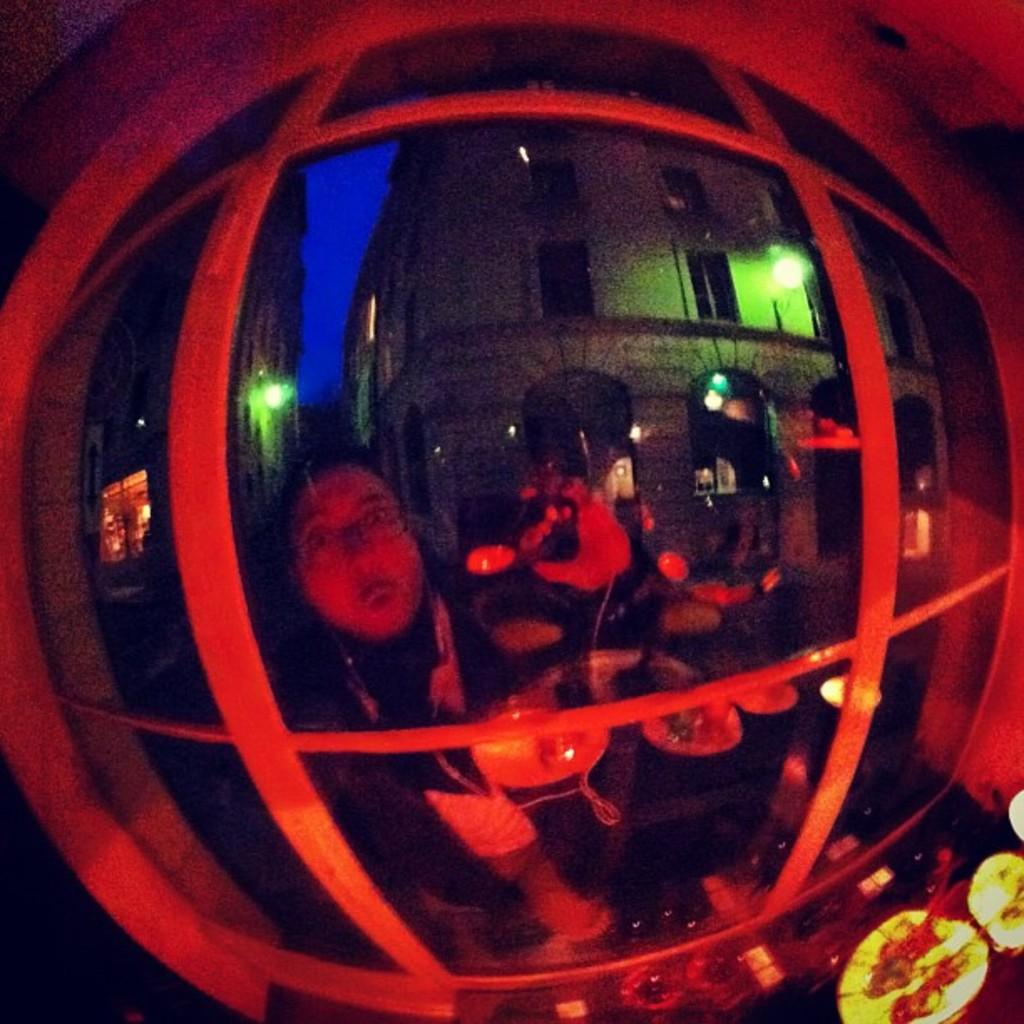What type of objects can be seen in the image? There are metal rods, lights, and tables in the image. What is the group of people doing in the image? The group of people is on the floor in the image. What type of structures are visible in the image? There are buildings in the image. What architectural features can be seen in the buildings? There are windows and doors in the image. What might suggest that the image was taken during a specific time of day? The image may have been taken during the night, as there are lights visible. Can you see a volcano erupting in the image? No, there is no volcano present in the image. What type of scissors are being used by the people on the floor? There are no scissors visible in the image. 